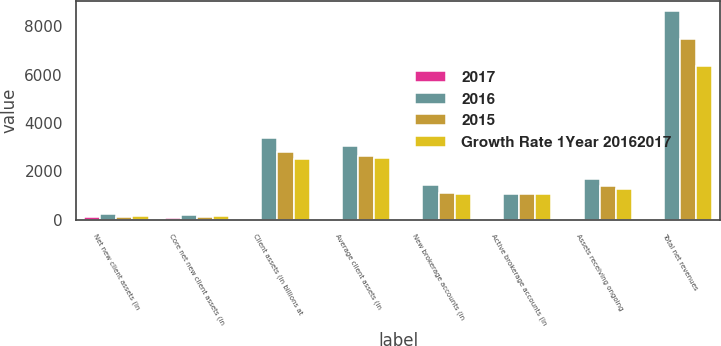Convert chart to OTSL. <chart><loc_0><loc_0><loc_500><loc_500><stacked_bar_chart><ecel><fcel>Net new client assets (in<fcel>Core net new client assets (in<fcel>Client assets (in billions at<fcel>Average client assets (in<fcel>New brokerage accounts (in<fcel>Active brokerage accounts (in<fcel>Assets receiving ongoing<fcel>Total net revenues<nl><fcel>2017<fcel>86<fcel>58<fcel>21<fcel>17<fcel>32<fcel>6<fcel>21<fcel>15<nl><fcel>2016<fcel>233.1<fcel>198.6<fcel>3361.8<fcel>3060.2<fcel>1441<fcel>1070<fcel>1699.8<fcel>8618<nl><fcel>2015<fcel>125.5<fcel>125.5<fcel>2779.5<fcel>2614.7<fcel>1093<fcel>1070<fcel>1401.4<fcel>7478<nl><fcel>Growth Rate 1Year 20162017<fcel>139.4<fcel>134.7<fcel>2513.8<fcel>2531.8<fcel>1070<fcel>1070<fcel>1253.7<fcel>6380<nl></chart> 